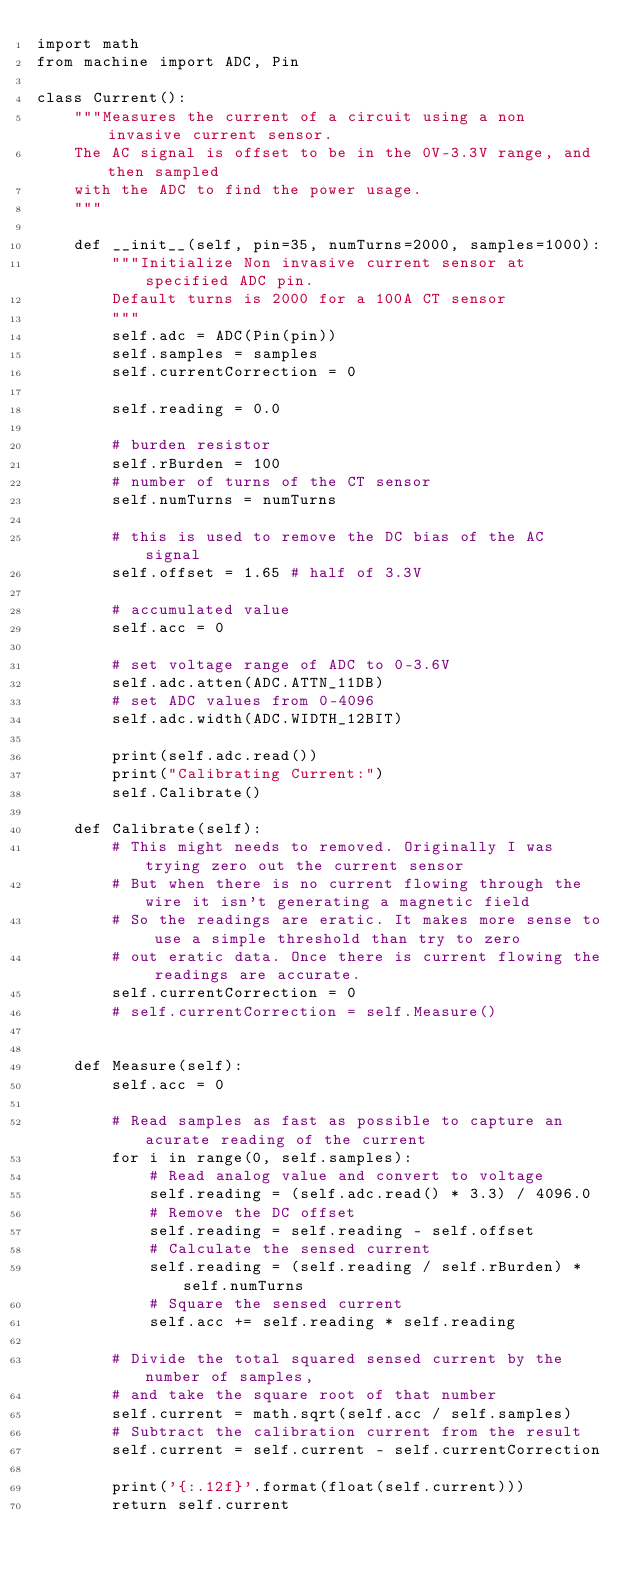<code> <loc_0><loc_0><loc_500><loc_500><_Python_>import math
from machine import ADC, Pin

class Current():
    """Measures the current of a circuit using a non invasive current sensor. 
    The AC signal is offset to be in the 0V-3.3V range, and then sampled 
    with the ADC to find the power usage.
    """

    def __init__(self, pin=35, numTurns=2000, samples=1000):
        """Initialize Non invasive current sensor at specified ADC pin. 
        Default turns is 2000 for a 100A CT sensor
        """
        self.adc = ADC(Pin(pin))
        self.samples = samples
        self.currentCorrection = 0

        self.reading = 0.0

        # burden resistor
        self.rBurden = 100
        # number of turns of the CT sensor
        self.numTurns = numTurns

        # this is used to remove the DC bias of the AC signal
        self.offset = 1.65 # half of 3.3V
        
        # accumulated value
        self.acc = 0

        # set voltage range of ADC to 0-3.6V
        self.adc.atten(ADC.ATTN_11DB)
        # set ADC values from 0-4096
        self.adc.width(ADC.WIDTH_12BIT)

        print(self.adc.read())
        print("Calibrating Current:")
        self.Calibrate()

    def Calibrate(self):
        # This might needs to removed. Originally I was trying zero out the current sensor
        # But when there is no current flowing through the wire it isn't generating a magnetic field
        # So the readings are eratic. It makes more sense to use a simple threshold than try to zero
        # out eratic data. Once there is current flowing the readings are accurate.
        self.currentCorrection = 0
        # self.currentCorrection = self.Measure()


    def Measure(self):
        self.acc = 0

        # Read samples as fast as possible to capture an acurate reading of the current
        for i in range(0, self.samples):
            # Read analog value and convert to voltage
            self.reading = (self.adc.read() * 3.3) / 4096.0
            # Remove the DC offset
            self.reading = self.reading - self.offset
            # Calculate the sensed current
            self.reading = (self.reading / self.rBurden) * self.numTurns
            # Square the sensed current
            self.acc += self.reading * self.reading

        # Divide the total squared sensed current by the number of samples, 
        # and take the square root of that number 
        self.current = math.sqrt(self.acc / self.samples)
        # Subtract the calibration current from the result
        self.current = self.current - self.currentCorrection
        
        print('{:.12f}'.format(float(self.current)))
        return self.current</code> 